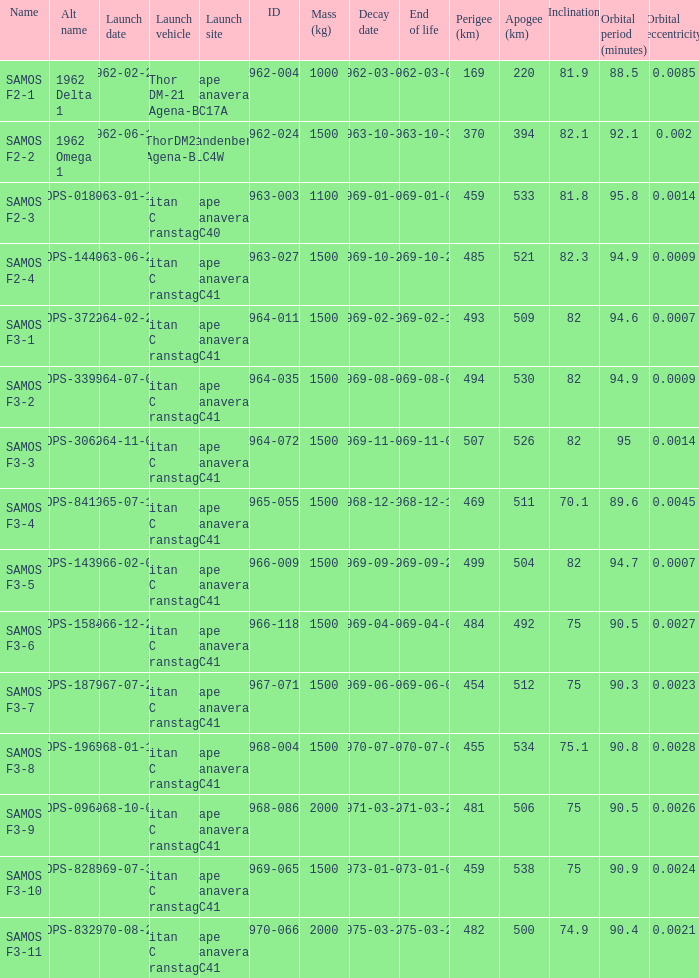What is the inclination when the alt name is OPS-1584? 75.0. 